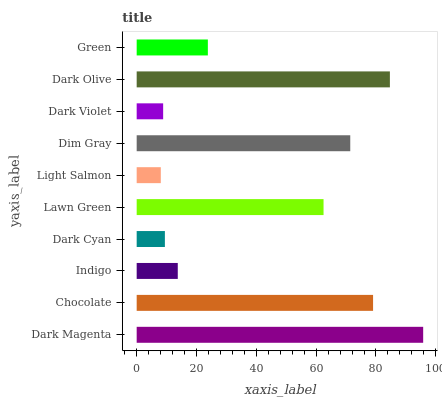Is Light Salmon the minimum?
Answer yes or no. Yes. Is Dark Magenta the maximum?
Answer yes or no. Yes. Is Chocolate the minimum?
Answer yes or no. No. Is Chocolate the maximum?
Answer yes or no. No. Is Dark Magenta greater than Chocolate?
Answer yes or no. Yes. Is Chocolate less than Dark Magenta?
Answer yes or no. Yes. Is Chocolate greater than Dark Magenta?
Answer yes or no. No. Is Dark Magenta less than Chocolate?
Answer yes or no. No. Is Lawn Green the high median?
Answer yes or no. Yes. Is Green the low median?
Answer yes or no. Yes. Is Dark Cyan the high median?
Answer yes or no. No. Is Light Salmon the low median?
Answer yes or no. No. 